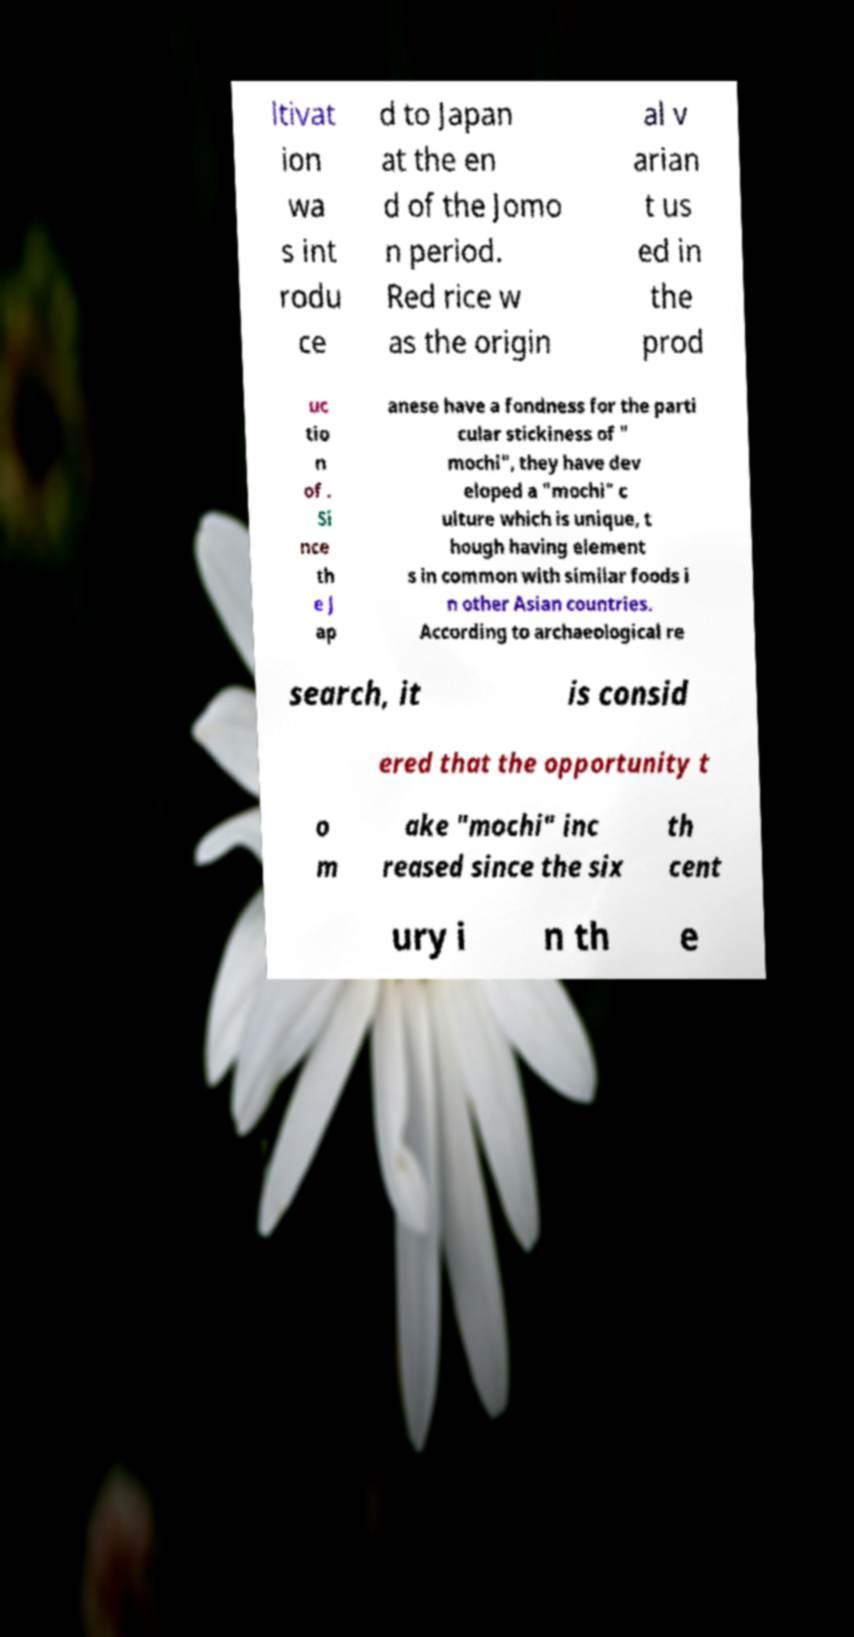Please identify and transcribe the text found in this image. ltivat ion wa s int rodu ce d to Japan at the en d of the Jomo n period. Red rice w as the origin al v arian t us ed in the prod uc tio n of . Si nce th e J ap anese have a fondness for the parti cular stickiness of " mochi", they have dev eloped a "mochi" c ulture which is unique, t hough having element s in common with similar foods i n other Asian countries. According to archaeological re search, it is consid ered that the opportunity t o m ake "mochi" inc reased since the six th cent ury i n th e 